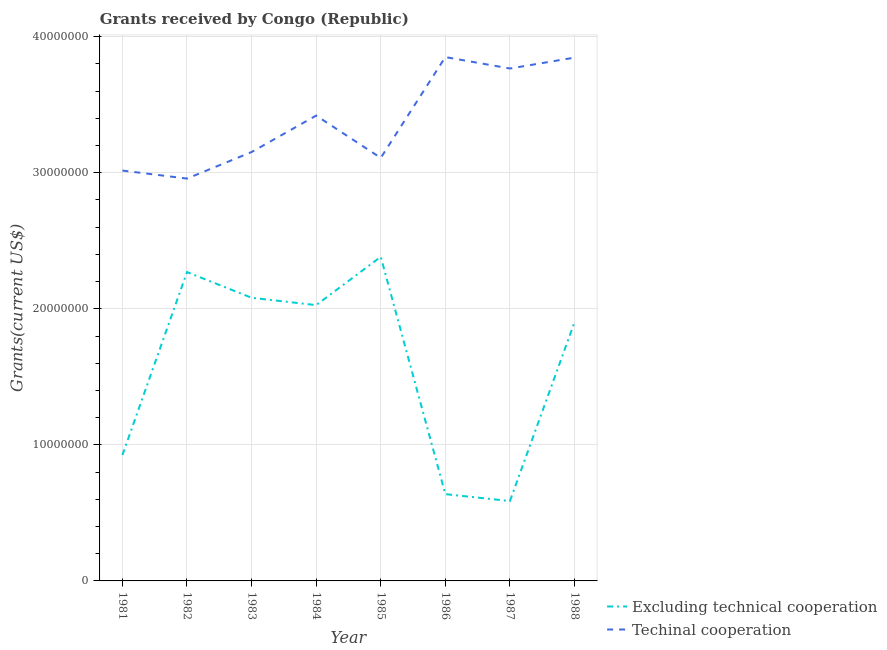Does the line corresponding to amount of grants received(excluding technical cooperation) intersect with the line corresponding to amount of grants received(including technical cooperation)?
Keep it short and to the point. No. What is the amount of grants received(including technical cooperation) in 1984?
Your response must be concise. 3.42e+07. Across all years, what is the maximum amount of grants received(including technical cooperation)?
Give a very brief answer. 3.85e+07. Across all years, what is the minimum amount of grants received(excluding technical cooperation)?
Give a very brief answer. 5.87e+06. In which year was the amount of grants received(excluding technical cooperation) maximum?
Your answer should be compact. 1985. What is the total amount of grants received(including technical cooperation) in the graph?
Offer a terse response. 2.71e+08. What is the difference between the amount of grants received(excluding technical cooperation) in 1981 and that in 1982?
Offer a terse response. -1.34e+07. What is the difference between the amount of grants received(including technical cooperation) in 1987 and the amount of grants received(excluding technical cooperation) in 1984?
Make the answer very short. 1.74e+07. What is the average amount of grants received(excluding technical cooperation) per year?
Ensure brevity in your answer.  1.60e+07. In the year 1984, what is the difference between the amount of grants received(including technical cooperation) and amount of grants received(excluding technical cooperation)?
Make the answer very short. 1.39e+07. In how many years, is the amount of grants received(including technical cooperation) greater than 26000000 US$?
Offer a terse response. 8. What is the ratio of the amount of grants received(excluding technical cooperation) in 1983 to that in 1985?
Offer a very short reply. 0.87. Is the amount of grants received(including technical cooperation) in 1982 less than that in 1988?
Your answer should be very brief. Yes. What is the difference between the highest and the second highest amount of grants received(including technical cooperation)?
Keep it short and to the point. 4.00e+04. What is the difference between the highest and the lowest amount of grants received(excluding technical cooperation)?
Provide a succinct answer. 1.80e+07. In how many years, is the amount of grants received(excluding technical cooperation) greater than the average amount of grants received(excluding technical cooperation) taken over all years?
Keep it short and to the point. 5. Does the amount of grants received(including technical cooperation) monotonically increase over the years?
Offer a terse response. No. Are the values on the major ticks of Y-axis written in scientific E-notation?
Give a very brief answer. No. Does the graph contain any zero values?
Offer a very short reply. No. Does the graph contain grids?
Your answer should be very brief. Yes. Where does the legend appear in the graph?
Your response must be concise. Bottom right. How many legend labels are there?
Offer a terse response. 2. How are the legend labels stacked?
Your answer should be compact. Vertical. What is the title of the graph?
Your answer should be very brief. Grants received by Congo (Republic). What is the label or title of the Y-axis?
Your answer should be compact. Grants(current US$). What is the Grants(current US$) of Excluding technical cooperation in 1981?
Offer a very short reply. 9.25e+06. What is the Grants(current US$) in Techinal cooperation in 1981?
Provide a short and direct response. 3.02e+07. What is the Grants(current US$) in Excluding technical cooperation in 1982?
Offer a terse response. 2.27e+07. What is the Grants(current US$) in Techinal cooperation in 1982?
Give a very brief answer. 2.96e+07. What is the Grants(current US$) of Excluding technical cooperation in 1983?
Ensure brevity in your answer.  2.08e+07. What is the Grants(current US$) in Techinal cooperation in 1983?
Your answer should be compact. 3.15e+07. What is the Grants(current US$) of Excluding technical cooperation in 1984?
Your answer should be compact. 2.03e+07. What is the Grants(current US$) in Techinal cooperation in 1984?
Your response must be concise. 3.42e+07. What is the Grants(current US$) in Excluding technical cooperation in 1985?
Provide a short and direct response. 2.38e+07. What is the Grants(current US$) of Techinal cooperation in 1985?
Provide a succinct answer. 3.11e+07. What is the Grants(current US$) in Excluding technical cooperation in 1986?
Make the answer very short. 6.38e+06. What is the Grants(current US$) in Techinal cooperation in 1986?
Your response must be concise. 3.85e+07. What is the Grants(current US$) of Excluding technical cooperation in 1987?
Offer a very short reply. 5.87e+06. What is the Grants(current US$) in Techinal cooperation in 1987?
Your response must be concise. 3.77e+07. What is the Grants(current US$) of Excluding technical cooperation in 1988?
Provide a short and direct response. 1.90e+07. What is the Grants(current US$) in Techinal cooperation in 1988?
Your answer should be compact. 3.85e+07. Across all years, what is the maximum Grants(current US$) of Excluding technical cooperation?
Offer a very short reply. 2.38e+07. Across all years, what is the maximum Grants(current US$) in Techinal cooperation?
Give a very brief answer. 3.85e+07. Across all years, what is the minimum Grants(current US$) of Excluding technical cooperation?
Your answer should be compact. 5.87e+06. Across all years, what is the minimum Grants(current US$) of Techinal cooperation?
Ensure brevity in your answer.  2.96e+07. What is the total Grants(current US$) of Excluding technical cooperation in the graph?
Your answer should be very brief. 1.28e+08. What is the total Grants(current US$) in Techinal cooperation in the graph?
Provide a succinct answer. 2.71e+08. What is the difference between the Grants(current US$) of Excluding technical cooperation in 1981 and that in 1982?
Provide a succinct answer. -1.34e+07. What is the difference between the Grants(current US$) of Techinal cooperation in 1981 and that in 1982?
Make the answer very short. 5.90e+05. What is the difference between the Grants(current US$) in Excluding technical cooperation in 1981 and that in 1983?
Give a very brief answer. -1.16e+07. What is the difference between the Grants(current US$) in Techinal cooperation in 1981 and that in 1983?
Offer a terse response. -1.36e+06. What is the difference between the Grants(current US$) in Excluding technical cooperation in 1981 and that in 1984?
Provide a short and direct response. -1.10e+07. What is the difference between the Grants(current US$) in Techinal cooperation in 1981 and that in 1984?
Provide a short and direct response. -4.04e+06. What is the difference between the Grants(current US$) in Excluding technical cooperation in 1981 and that in 1985?
Ensure brevity in your answer.  -1.46e+07. What is the difference between the Grants(current US$) of Techinal cooperation in 1981 and that in 1985?
Give a very brief answer. -9.30e+05. What is the difference between the Grants(current US$) of Excluding technical cooperation in 1981 and that in 1986?
Give a very brief answer. 2.87e+06. What is the difference between the Grants(current US$) in Techinal cooperation in 1981 and that in 1986?
Make the answer very short. -8.34e+06. What is the difference between the Grants(current US$) of Excluding technical cooperation in 1981 and that in 1987?
Provide a short and direct response. 3.38e+06. What is the difference between the Grants(current US$) in Techinal cooperation in 1981 and that in 1987?
Your answer should be compact. -7.50e+06. What is the difference between the Grants(current US$) in Excluding technical cooperation in 1981 and that in 1988?
Offer a very short reply. -9.76e+06. What is the difference between the Grants(current US$) of Techinal cooperation in 1981 and that in 1988?
Give a very brief answer. -8.30e+06. What is the difference between the Grants(current US$) of Excluding technical cooperation in 1982 and that in 1983?
Your answer should be very brief. 1.89e+06. What is the difference between the Grants(current US$) in Techinal cooperation in 1982 and that in 1983?
Give a very brief answer. -1.95e+06. What is the difference between the Grants(current US$) of Excluding technical cooperation in 1982 and that in 1984?
Offer a very short reply. 2.43e+06. What is the difference between the Grants(current US$) of Techinal cooperation in 1982 and that in 1984?
Keep it short and to the point. -4.63e+06. What is the difference between the Grants(current US$) in Excluding technical cooperation in 1982 and that in 1985?
Give a very brief answer. -1.12e+06. What is the difference between the Grants(current US$) in Techinal cooperation in 1982 and that in 1985?
Your answer should be compact. -1.52e+06. What is the difference between the Grants(current US$) of Excluding technical cooperation in 1982 and that in 1986?
Make the answer very short. 1.63e+07. What is the difference between the Grants(current US$) in Techinal cooperation in 1982 and that in 1986?
Your answer should be very brief. -8.93e+06. What is the difference between the Grants(current US$) of Excluding technical cooperation in 1982 and that in 1987?
Give a very brief answer. 1.68e+07. What is the difference between the Grants(current US$) in Techinal cooperation in 1982 and that in 1987?
Your response must be concise. -8.09e+06. What is the difference between the Grants(current US$) of Excluding technical cooperation in 1982 and that in 1988?
Your answer should be compact. 3.69e+06. What is the difference between the Grants(current US$) in Techinal cooperation in 1982 and that in 1988?
Your response must be concise. -8.89e+06. What is the difference between the Grants(current US$) of Excluding technical cooperation in 1983 and that in 1984?
Offer a very short reply. 5.40e+05. What is the difference between the Grants(current US$) of Techinal cooperation in 1983 and that in 1984?
Offer a terse response. -2.68e+06. What is the difference between the Grants(current US$) in Excluding technical cooperation in 1983 and that in 1985?
Give a very brief answer. -3.01e+06. What is the difference between the Grants(current US$) of Techinal cooperation in 1983 and that in 1985?
Keep it short and to the point. 4.30e+05. What is the difference between the Grants(current US$) of Excluding technical cooperation in 1983 and that in 1986?
Offer a very short reply. 1.44e+07. What is the difference between the Grants(current US$) of Techinal cooperation in 1983 and that in 1986?
Ensure brevity in your answer.  -6.98e+06. What is the difference between the Grants(current US$) of Excluding technical cooperation in 1983 and that in 1987?
Ensure brevity in your answer.  1.49e+07. What is the difference between the Grants(current US$) of Techinal cooperation in 1983 and that in 1987?
Provide a short and direct response. -6.14e+06. What is the difference between the Grants(current US$) in Excluding technical cooperation in 1983 and that in 1988?
Keep it short and to the point. 1.80e+06. What is the difference between the Grants(current US$) in Techinal cooperation in 1983 and that in 1988?
Give a very brief answer. -6.94e+06. What is the difference between the Grants(current US$) in Excluding technical cooperation in 1984 and that in 1985?
Offer a very short reply. -3.55e+06. What is the difference between the Grants(current US$) in Techinal cooperation in 1984 and that in 1985?
Your response must be concise. 3.11e+06. What is the difference between the Grants(current US$) of Excluding technical cooperation in 1984 and that in 1986?
Your answer should be very brief. 1.39e+07. What is the difference between the Grants(current US$) in Techinal cooperation in 1984 and that in 1986?
Your answer should be very brief. -4.30e+06. What is the difference between the Grants(current US$) in Excluding technical cooperation in 1984 and that in 1987?
Offer a very short reply. 1.44e+07. What is the difference between the Grants(current US$) in Techinal cooperation in 1984 and that in 1987?
Your response must be concise. -3.46e+06. What is the difference between the Grants(current US$) in Excluding technical cooperation in 1984 and that in 1988?
Offer a very short reply. 1.26e+06. What is the difference between the Grants(current US$) of Techinal cooperation in 1984 and that in 1988?
Your response must be concise. -4.26e+06. What is the difference between the Grants(current US$) in Excluding technical cooperation in 1985 and that in 1986?
Offer a very short reply. 1.74e+07. What is the difference between the Grants(current US$) in Techinal cooperation in 1985 and that in 1986?
Provide a succinct answer. -7.41e+06. What is the difference between the Grants(current US$) of Excluding technical cooperation in 1985 and that in 1987?
Offer a terse response. 1.80e+07. What is the difference between the Grants(current US$) in Techinal cooperation in 1985 and that in 1987?
Make the answer very short. -6.57e+06. What is the difference between the Grants(current US$) of Excluding technical cooperation in 1985 and that in 1988?
Make the answer very short. 4.81e+06. What is the difference between the Grants(current US$) in Techinal cooperation in 1985 and that in 1988?
Provide a succinct answer. -7.37e+06. What is the difference between the Grants(current US$) of Excluding technical cooperation in 1986 and that in 1987?
Keep it short and to the point. 5.10e+05. What is the difference between the Grants(current US$) in Techinal cooperation in 1986 and that in 1987?
Provide a succinct answer. 8.40e+05. What is the difference between the Grants(current US$) in Excluding technical cooperation in 1986 and that in 1988?
Offer a terse response. -1.26e+07. What is the difference between the Grants(current US$) of Excluding technical cooperation in 1987 and that in 1988?
Your response must be concise. -1.31e+07. What is the difference between the Grants(current US$) in Techinal cooperation in 1987 and that in 1988?
Your answer should be very brief. -8.00e+05. What is the difference between the Grants(current US$) of Excluding technical cooperation in 1981 and the Grants(current US$) of Techinal cooperation in 1982?
Your response must be concise. -2.03e+07. What is the difference between the Grants(current US$) of Excluding technical cooperation in 1981 and the Grants(current US$) of Techinal cooperation in 1983?
Provide a succinct answer. -2.23e+07. What is the difference between the Grants(current US$) of Excluding technical cooperation in 1981 and the Grants(current US$) of Techinal cooperation in 1984?
Offer a terse response. -2.50e+07. What is the difference between the Grants(current US$) in Excluding technical cooperation in 1981 and the Grants(current US$) in Techinal cooperation in 1985?
Provide a short and direct response. -2.18e+07. What is the difference between the Grants(current US$) of Excluding technical cooperation in 1981 and the Grants(current US$) of Techinal cooperation in 1986?
Offer a very short reply. -2.92e+07. What is the difference between the Grants(current US$) of Excluding technical cooperation in 1981 and the Grants(current US$) of Techinal cooperation in 1987?
Your answer should be compact. -2.84e+07. What is the difference between the Grants(current US$) of Excluding technical cooperation in 1981 and the Grants(current US$) of Techinal cooperation in 1988?
Ensure brevity in your answer.  -2.92e+07. What is the difference between the Grants(current US$) in Excluding technical cooperation in 1982 and the Grants(current US$) in Techinal cooperation in 1983?
Ensure brevity in your answer.  -8.82e+06. What is the difference between the Grants(current US$) in Excluding technical cooperation in 1982 and the Grants(current US$) in Techinal cooperation in 1984?
Provide a short and direct response. -1.15e+07. What is the difference between the Grants(current US$) in Excluding technical cooperation in 1982 and the Grants(current US$) in Techinal cooperation in 1985?
Offer a very short reply. -8.39e+06. What is the difference between the Grants(current US$) of Excluding technical cooperation in 1982 and the Grants(current US$) of Techinal cooperation in 1986?
Give a very brief answer. -1.58e+07. What is the difference between the Grants(current US$) of Excluding technical cooperation in 1982 and the Grants(current US$) of Techinal cooperation in 1987?
Offer a very short reply. -1.50e+07. What is the difference between the Grants(current US$) of Excluding technical cooperation in 1982 and the Grants(current US$) of Techinal cooperation in 1988?
Ensure brevity in your answer.  -1.58e+07. What is the difference between the Grants(current US$) of Excluding technical cooperation in 1983 and the Grants(current US$) of Techinal cooperation in 1984?
Provide a short and direct response. -1.34e+07. What is the difference between the Grants(current US$) in Excluding technical cooperation in 1983 and the Grants(current US$) in Techinal cooperation in 1985?
Ensure brevity in your answer.  -1.03e+07. What is the difference between the Grants(current US$) of Excluding technical cooperation in 1983 and the Grants(current US$) of Techinal cooperation in 1986?
Ensure brevity in your answer.  -1.77e+07. What is the difference between the Grants(current US$) in Excluding technical cooperation in 1983 and the Grants(current US$) in Techinal cooperation in 1987?
Provide a short and direct response. -1.68e+07. What is the difference between the Grants(current US$) of Excluding technical cooperation in 1983 and the Grants(current US$) of Techinal cooperation in 1988?
Offer a terse response. -1.76e+07. What is the difference between the Grants(current US$) in Excluding technical cooperation in 1984 and the Grants(current US$) in Techinal cooperation in 1985?
Your answer should be compact. -1.08e+07. What is the difference between the Grants(current US$) of Excluding technical cooperation in 1984 and the Grants(current US$) of Techinal cooperation in 1986?
Provide a short and direct response. -1.82e+07. What is the difference between the Grants(current US$) of Excluding technical cooperation in 1984 and the Grants(current US$) of Techinal cooperation in 1987?
Your answer should be very brief. -1.74e+07. What is the difference between the Grants(current US$) in Excluding technical cooperation in 1984 and the Grants(current US$) in Techinal cooperation in 1988?
Offer a terse response. -1.82e+07. What is the difference between the Grants(current US$) of Excluding technical cooperation in 1985 and the Grants(current US$) of Techinal cooperation in 1986?
Give a very brief answer. -1.47e+07. What is the difference between the Grants(current US$) of Excluding technical cooperation in 1985 and the Grants(current US$) of Techinal cooperation in 1987?
Provide a succinct answer. -1.38e+07. What is the difference between the Grants(current US$) of Excluding technical cooperation in 1985 and the Grants(current US$) of Techinal cooperation in 1988?
Offer a very short reply. -1.46e+07. What is the difference between the Grants(current US$) of Excluding technical cooperation in 1986 and the Grants(current US$) of Techinal cooperation in 1987?
Ensure brevity in your answer.  -3.13e+07. What is the difference between the Grants(current US$) of Excluding technical cooperation in 1986 and the Grants(current US$) of Techinal cooperation in 1988?
Offer a very short reply. -3.21e+07. What is the difference between the Grants(current US$) in Excluding technical cooperation in 1987 and the Grants(current US$) in Techinal cooperation in 1988?
Give a very brief answer. -3.26e+07. What is the average Grants(current US$) of Excluding technical cooperation per year?
Ensure brevity in your answer.  1.60e+07. What is the average Grants(current US$) of Techinal cooperation per year?
Your answer should be very brief. 3.39e+07. In the year 1981, what is the difference between the Grants(current US$) in Excluding technical cooperation and Grants(current US$) in Techinal cooperation?
Make the answer very short. -2.09e+07. In the year 1982, what is the difference between the Grants(current US$) of Excluding technical cooperation and Grants(current US$) of Techinal cooperation?
Keep it short and to the point. -6.87e+06. In the year 1983, what is the difference between the Grants(current US$) in Excluding technical cooperation and Grants(current US$) in Techinal cooperation?
Your answer should be very brief. -1.07e+07. In the year 1984, what is the difference between the Grants(current US$) of Excluding technical cooperation and Grants(current US$) of Techinal cooperation?
Make the answer very short. -1.39e+07. In the year 1985, what is the difference between the Grants(current US$) of Excluding technical cooperation and Grants(current US$) of Techinal cooperation?
Offer a very short reply. -7.27e+06. In the year 1986, what is the difference between the Grants(current US$) in Excluding technical cooperation and Grants(current US$) in Techinal cooperation?
Give a very brief answer. -3.21e+07. In the year 1987, what is the difference between the Grants(current US$) of Excluding technical cooperation and Grants(current US$) of Techinal cooperation?
Provide a short and direct response. -3.18e+07. In the year 1988, what is the difference between the Grants(current US$) of Excluding technical cooperation and Grants(current US$) of Techinal cooperation?
Ensure brevity in your answer.  -1.94e+07. What is the ratio of the Grants(current US$) of Excluding technical cooperation in 1981 to that in 1982?
Offer a terse response. 0.41. What is the ratio of the Grants(current US$) in Excluding technical cooperation in 1981 to that in 1983?
Your answer should be very brief. 0.44. What is the ratio of the Grants(current US$) in Techinal cooperation in 1981 to that in 1983?
Ensure brevity in your answer.  0.96. What is the ratio of the Grants(current US$) in Excluding technical cooperation in 1981 to that in 1984?
Offer a terse response. 0.46. What is the ratio of the Grants(current US$) of Techinal cooperation in 1981 to that in 1984?
Your answer should be very brief. 0.88. What is the ratio of the Grants(current US$) of Excluding technical cooperation in 1981 to that in 1985?
Offer a terse response. 0.39. What is the ratio of the Grants(current US$) of Techinal cooperation in 1981 to that in 1985?
Your response must be concise. 0.97. What is the ratio of the Grants(current US$) of Excluding technical cooperation in 1981 to that in 1986?
Keep it short and to the point. 1.45. What is the ratio of the Grants(current US$) in Techinal cooperation in 1981 to that in 1986?
Your response must be concise. 0.78. What is the ratio of the Grants(current US$) of Excluding technical cooperation in 1981 to that in 1987?
Your response must be concise. 1.58. What is the ratio of the Grants(current US$) of Techinal cooperation in 1981 to that in 1987?
Your answer should be compact. 0.8. What is the ratio of the Grants(current US$) in Excluding technical cooperation in 1981 to that in 1988?
Give a very brief answer. 0.49. What is the ratio of the Grants(current US$) in Techinal cooperation in 1981 to that in 1988?
Your answer should be very brief. 0.78. What is the ratio of the Grants(current US$) of Excluding technical cooperation in 1982 to that in 1983?
Keep it short and to the point. 1.09. What is the ratio of the Grants(current US$) of Techinal cooperation in 1982 to that in 1983?
Your answer should be very brief. 0.94. What is the ratio of the Grants(current US$) in Excluding technical cooperation in 1982 to that in 1984?
Your answer should be compact. 1.12. What is the ratio of the Grants(current US$) of Techinal cooperation in 1982 to that in 1984?
Offer a very short reply. 0.86. What is the ratio of the Grants(current US$) in Excluding technical cooperation in 1982 to that in 1985?
Keep it short and to the point. 0.95. What is the ratio of the Grants(current US$) of Techinal cooperation in 1982 to that in 1985?
Keep it short and to the point. 0.95. What is the ratio of the Grants(current US$) of Excluding technical cooperation in 1982 to that in 1986?
Your response must be concise. 3.56. What is the ratio of the Grants(current US$) of Techinal cooperation in 1982 to that in 1986?
Provide a short and direct response. 0.77. What is the ratio of the Grants(current US$) of Excluding technical cooperation in 1982 to that in 1987?
Your answer should be very brief. 3.87. What is the ratio of the Grants(current US$) of Techinal cooperation in 1982 to that in 1987?
Your answer should be very brief. 0.79. What is the ratio of the Grants(current US$) of Excluding technical cooperation in 1982 to that in 1988?
Make the answer very short. 1.19. What is the ratio of the Grants(current US$) of Techinal cooperation in 1982 to that in 1988?
Your response must be concise. 0.77. What is the ratio of the Grants(current US$) of Excluding technical cooperation in 1983 to that in 1984?
Give a very brief answer. 1.03. What is the ratio of the Grants(current US$) in Techinal cooperation in 1983 to that in 1984?
Offer a terse response. 0.92. What is the ratio of the Grants(current US$) in Excluding technical cooperation in 1983 to that in 1985?
Offer a very short reply. 0.87. What is the ratio of the Grants(current US$) of Techinal cooperation in 1983 to that in 1985?
Ensure brevity in your answer.  1.01. What is the ratio of the Grants(current US$) in Excluding technical cooperation in 1983 to that in 1986?
Your response must be concise. 3.26. What is the ratio of the Grants(current US$) of Techinal cooperation in 1983 to that in 1986?
Provide a short and direct response. 0.82. What is the ratio of the Grants(current US$) of Excluding technical cooperation in 1983 to that in 1987?
Offer a terse response. 3.55. What is the ratio of the Grants(current US$) in Techinal cooperation in 1983 to that in 1987?
Provide a short and direct response. 0.84. What is the ratio of the Grants(current US$) in Excluding technical cooperation in 1983 to that in 1988?
Your response must be concise. 1.09. What is the ratio of the Grants(current US$) in Techinal cooperation in 1983 to that in 1988?
Your response must be concise. 0.82. What is the ratio of the Grants(current US$) of Excluding technical cooperation in 1984 to that in 1985?
Your response must be concise. 0.85. What is the ratio of the Grants(current US$) in Techinal cooperation in 1984 to that in 1985?
Keep it short and to the point. 1.1. What is the ratio of the Grants(current US$) in Excluding technical cooperation in 1984 to that in 1986?
Make the answer very short. 3.18. What is the ratio of the Grants(current US$) of Techinal cooperation in 1984 to that in 1986?
Provide a short and direct response. 0.89. What is the ratio of the Grants(current US$) of Excluding technical cooperation in 1984 to that in 1987?
Offer a terse response. 3.45. What is the ratio of the Grants(current US$) of Techinal cooperation in 1984 to that in 1987?
Offer a terse response. 0.91. What is the ratio of the Grants(current US$) of Excluding technical cooperation in 1984 to that in 1988?
Keep it short and to the point. 1.07. What is the ratio of the Grants(current US$) in Techinal cooperation in 1984 to that in 1988?
Offer a terse response. 0.89. What is the ratio of the Grants(current US$) of Excluding technical cooperation in 1985 to that in 1986?
Make the answer very short. 3.73. What is the ratio of the Grants(current US$) of Techinal cooperation in 1985 to that in 1986?
Your answer should be compact. 0.81. What is the ratio of the Grants(current US$) in Excluding technical cooperation in 1985 to that in 1987?
Offer a terse response. 4.06. What is the ratio of the Grants(current US$) in Techinal cooperation in 1985 to that in 1987?
Provide a short and direct response. 0.83. What is the ratio of the Grants(current US$) of Excluding technical cooperation in 1985 to that in 1988?
Provide a succinct answer. 1.25. What is the ratio of the Grants(current US$) in Techinal cooperation in 1985 to that in 1988?
Give a very brief answer. 0.81. What is the ratio of the Grants(current US$) in Excluding technical cooperation in 1986 to that in 1987?
Give a very brief answer. 1.09. What is the ratio of the Grants(current US$) of Techinal cooperation in 1986 to that in 1987?
Provide a succinct answer. 1.02. What is the ratio of the Grants(current US$) in Excluding technical cooperation in 1986 to that in 1988?
Keep it short and to the point. 0.34. What is the ratio of the Grants(current US$) in Excluding technical cooperation in 1987 to that in 1988?
Provide a short and direct response. 0.31. What is the ratio of the Grants(current US$) in Techinal cooperation in 1987 to that in 1988?
Provide a short and direct response. 0.98. What is the difference between the highest and the second highest Grants(current US$) in Excluding technical cooperation?
Ensure brevity in your answer.  1.12e+06. What is the difference between the highest and the lowest Grants(current US$) in Excluding technical cooperation?
Your answer should be very brief. 1.80e+07. What is the difference between the highest and the lowest Grants(current US$) in Techinal cooperation?
Your answer should be very brief. 8.93e+06. 